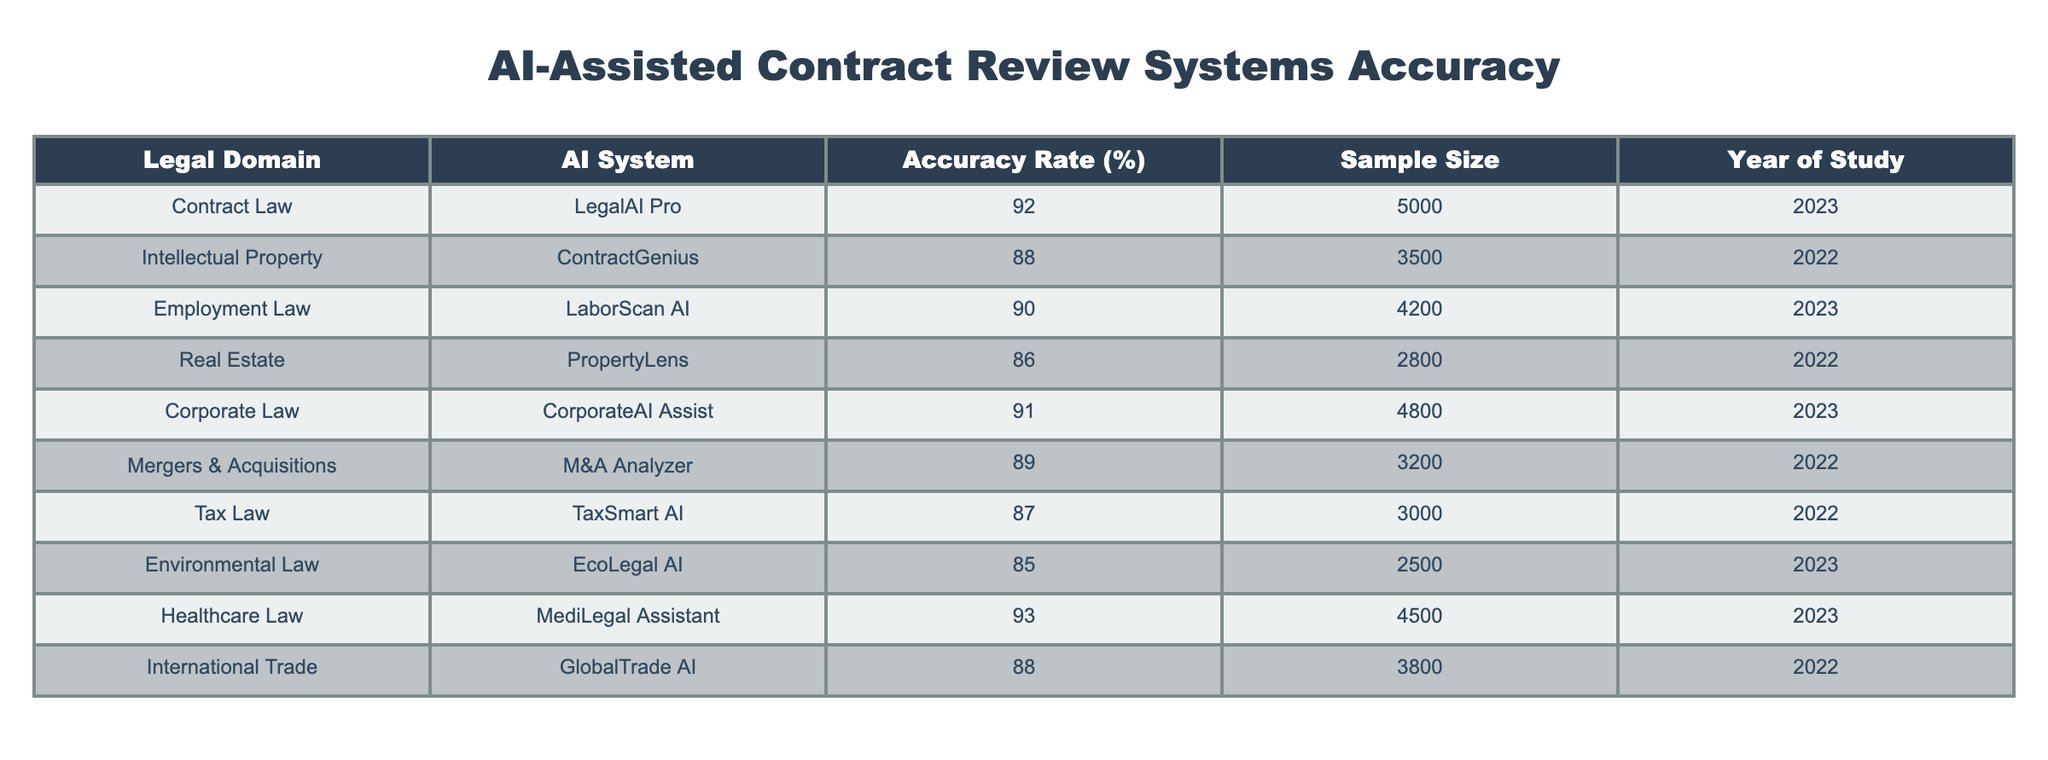What is the accuracy rate of the AI system used in Healthcare Law? According to the table, the AI system in Healthcare Law is MediLegal Assistant, which has an accuracy rate of 93%.
Answer: 93% Which AI system has the highest accuracy rate? The table shows that the Healthcare Law system, MediLegal Assistant, has the highest accuracy rate of 93%.
Answer: MediLegal Assistant Calculate the average accuracy rate of AI systems across all legal domains listed. To find the average, sum all the accuracy rates: (92 + 88 + 90 + 86 + 91 + 89 + 87 + 85 + 93 + 88) = 918. There are 10 systems, so the average is 918 / 10 = 91.8%.
Answer: 91.8% Is the accuracy rate of AI systems in Employment Law greater than that in Real Estate? The accuracy rate for Employment Law (90%) is greater than that for Real Estate (86%), confirming that Employment Law has a higher rate.
Answer: Yes What is the difference in accuracy rates between the AI systems for Corporate Law and Tax Law? CorporateAI Assist in Corporate Law has an accuracy rate of 91%, while TaxSmart AI in Tax Law has an accuracy rate of 87%. The difference is 91% - 87% = 4%.
Answer: 4% Did any AI system achieve an accuracy rate lower than 85%? Upon reviewing the table, the lowest accuracy rate was 85% for EcoLegal AI in Environmental Law, indicating no system fell below that threshold.
Answer: No How many AI systems have an accuracy rate above 90%? The table lists four AI systems: LegalAI Pro (92%), LaborScan AI (90%), CorporateAI Assist (91%), and MediLegal Assistant (93%). Therefore, four systems have rates above 90%.
Answer: 4 How does the accuracy rate of Contract Law compare to that of Intellectual Property? Contract Law's accuracy rate is 92%, while Intellectual Property's is 88%. The difference is that Contract Law is 4% higher than Intellectual Property.
Answer: 4% higher What is the total sample size for AI systems in 2023? The AI systems in 2023 are LegalAI Pro (5000), LaborScan AI (4200), CorporateAI Assist (4800), and MediLegal Assistant (4500). The total sample size is 5000 + 4200 + 4800 + 4500 = 18500.
Answer: 18500 